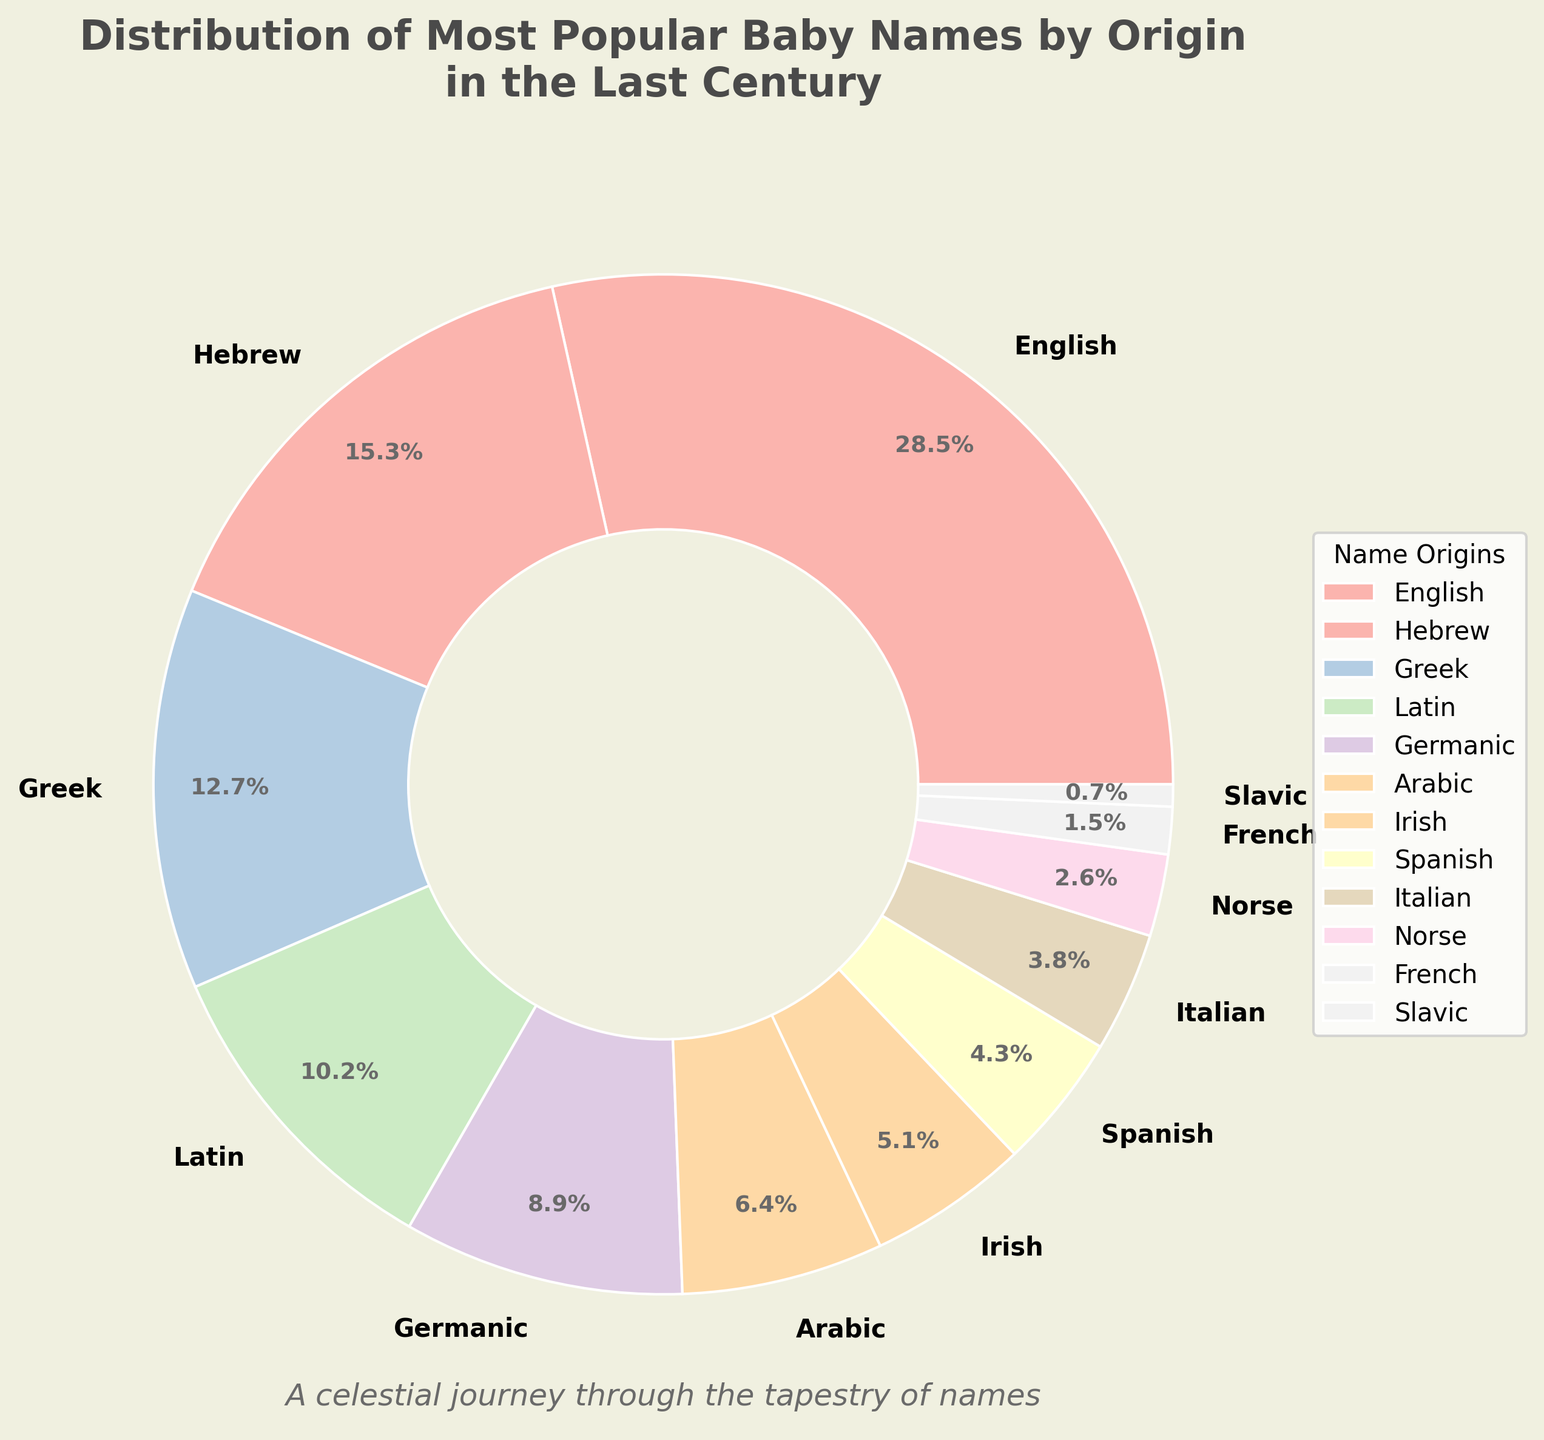what is the most popular baby name origin? The pie chart shows different origin categories with their respective percentages. The largest section, representing 28.5% of the total, corresponds to the "English" origin, indicating it is the most popular.
Answer: English which origin has a slightly greater percentage than Arabic? By inspecting the pie chart, Arabic origin accounts for 6.4% of the total. The section slightly larger than Arabic's is labeled "Germanic," which accounts for 8.9% of the total.
Answer: Germanic what is the combined percentage of Latin and Greek origins? From the pie chart, Latin origin accounts for 10.2% and Greek origin accounts for 12.7%. Adding these percentages together gives 10.2% + 12.7% = 22.9%.
Answer: 22.9% what is the total percentage of origins accounting for less than 5% each? Inspect each origin's percentage: Irish (5.1%), Spanish (4.3%), Italian (3.8%), Norse (2.6%), French (1.5%), and Slavic (0.7%). Only Spanish, Italian, Norse, French, and Slavic have less than 5% each. Sum these values: 4.3% + 3.8% + 2.6% + 1.5% + 0.7% = 12.9%.
Answer: 12.9% which origin category has the least percentage? The smallest section on the pie chart corresponds to the "Slavic" origin, with a percentage of 0.7%.
Answer: Slavic how does the percentage of Hebrew names compare to Irish names? The pie chart shows Hebrew origin with 15.3% and Irish origin with 5.1%. Hebrew is more popular than Irish, as 15.3% is greater than 5.1%.
Answer: Hebrew is more popular what is the visual color associated with Greek origin in the pie chart? Each origin in the pie chart is represented by a colored section. Greek origin is represented by its respective color, which is part of the custom pastel palette used in the chart. Specifically, on the pie chart, the Greek section is a shade of pastel pink.
Answer: pastel pink 